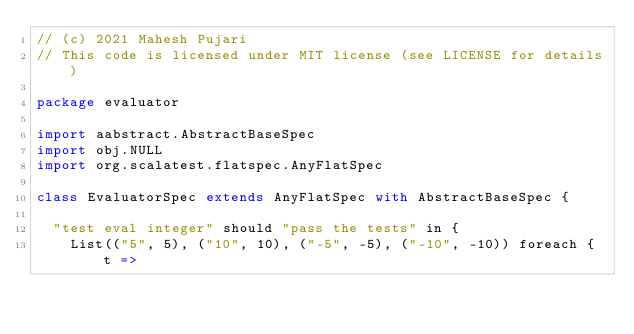Convert code to text. <code><loc_0><loc_0><loc_500><loc_500><_Scala_>// (c) 2021 Mahesh Pujari
// This code is licensed under MIT license (see LICENSE for details)

package evaluator

import aabstract.AbstractBaseSpec
import obj.NULL
import org.scalatest.flatspec.AnyFlatSpec

class EvaluatorSpec extends AnyFlatSpec with AbstractBaseSpec {

  "test eval integer" should "pass the tests" in {
    List(("5", 5), ("10", 10), ("-5", -5), ("-10", -10)) foreach { t =></code> 